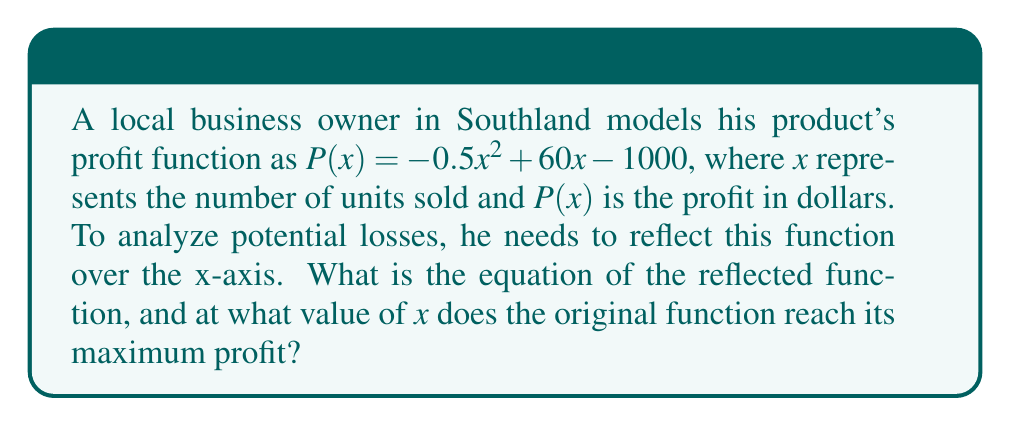Solve this math problem. 1) To reflect a function over the x-axis, we multiply the entire function by -1:
   
   Original function: $P(x) = -0.5x^2 + 60x - 1000$
   Reflected function: $R(x) = -(-0.5x^2 + 60x - 1000) = 0.5x^2 - 60x + 1000$

2) To find the maximum profit of the original function:
   a) The function is a parabola opening downward (coefficient of $x^2$ is negative).
   b) The vertex of the parabola represents the maximum point.
   c) For a quadratic function $ax^2 + bx + c$, the x-coordinate of the vertex is given by $x = -\frac{b}{2a}$

3) In this case, $a = -0.5$, $b = 60$:
   
   $x = -\frac{60}{2(-0.5)} = -\frac{60}{-1} = 60$

4) Therefore, the maximum profit occurs when $x = 60$ units are sold.
Answer: $R(x) = 0.5x^2 - 60x + 1000$; Maximum at $x = 60$ 